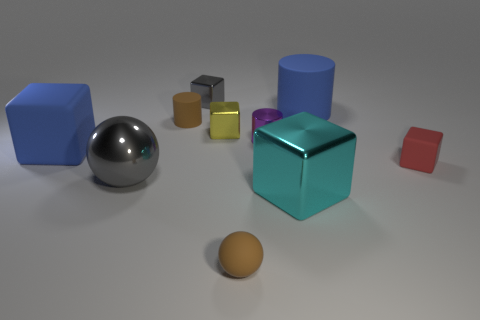Are there more blue things behind the metal cylinder than tiny green blocks?
Ensure brevity in your answer.  Yes. Is the small cylinder left of the brown matte ball made of the same material as the yellow thing?
Keep it short and to the point. No. There is a blue object behind the big matte thing in front of the blue rubber thing that is right of the small sphere; what size is it?
Offer a very short reply. Large. There is a blue cube that is made of the same material as the tiny brown sphere; what is its size?
Provide a short and direct response. Large. What color is the rubber thing that is on the right side of the tiny brown sphere and in front of the blue rubber block?
Offer a very short reply. Red. There is a big metal thing that is right of the large gray shiny sphere; is its shape the same as the large blue rubber object on the left side of the large gray shiny sphere?
Provide a short and direct response. Yes. What material is the red cube right of the brown sphere?
Your answer should be very brief. Rubber. What size is the matte ball that is the same color as the small rubber cylinder?
Ensure brevity in your answer.  Small. How many objects are big blue matte objects that are behind the brown cylinder or rubber cubes?
Ensure brevity in your answer.  3. Are there an equal number of blue blocks to the right of the small brown cylinder and large red metallic spheres?
Your answer should be very brief. Yes. 